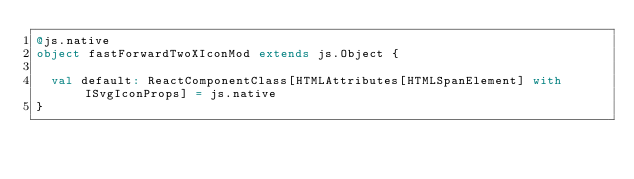<code> <loc_0><loc_0><loc_500><loc_500><_Scala_>@js.native
object fastForwardTwoXIconMod extends js.Object {
  
  val default: ReactComponentClass[HTMLAttributes[HTMLSpanElement] with ISvgIconProps] = js.native
}
</code> 